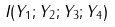<formula> <loc_0><loc_0><loc_500><loc_500>I ( Y _ { 1 } ; Y _ { 2 } ; Y _ { 3 } ; Y _ { 4 } )</formula> 